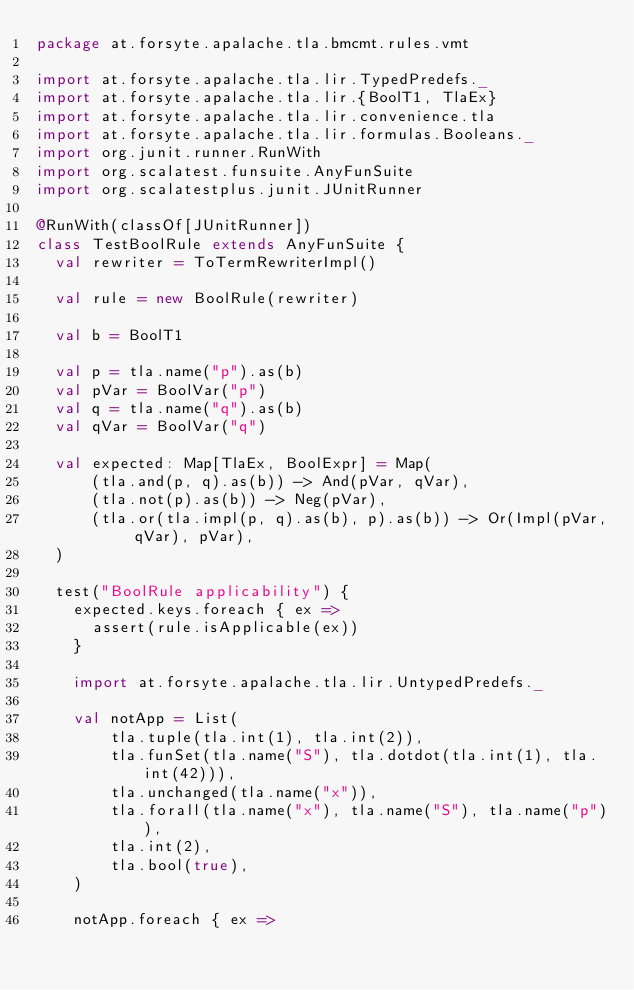<code> <loc_0><loc_0><loc_500><loc_500><_Scala_>package at.forsyte.apalache.tla.bmcmt.rules.vmt

import at.forsyte.apalache.tla.lir.TypedPredefs._
import at.forsyte.apalache.tla.lir.{BoolT1, TlaEx}
import at.forsyte.apalache.tla.lir.convenience.tla
import at.forsyte.apalache.tla.lir.formulas.Booleans._
import org.junit.runner.RunWith
import org.scalatest.funsuite.AnyFunSuite
import org.scalatestplus.junit.JUnitRunner

@RunWith(classOf[JUnitRunner])
class TestBoolRule extends AnyFunSuite {
  val rewriter = ToTermRewriterImpl()

  val rule = new BoolRule(rewriter)

  val b = BoolT1

  val p = tla.name("p").as(b)
  val pVar = BoolVar("p")
  val q = tla.name("q").as(b)
  val qVar = BoolVar("q")

  val expected: Map[TlaEx, BoolExpr] = Map(
      (tla.and(p, q).as(b)) -> And(pVar, qVar),
      (tla.not(p).as(b)) -> Neg(pVar),
      (tla.or(tla.impl(p, q).as(b), p).as(b)) -> Or(Impl(pVar, qVar), pVar),
  )

  test("BoolRule applicability") {
    expected.keys.foreach { ex =>
      assert(rule.isApplicable(ex))
    }

    import at.forsyte.apalache.tla.lir.UntypedPredefs._

    val notApp = List(
        tla.tuple(tla.int(1), tla.int(2)),
        tla.funSet(tla.name("S"), tla.dotdot(tla.int(1), tla.int(42))),
        tla.unchanged(tla.name("x")),
        tla.forall(tla.name("x"), tla.name("S"), tla.name("p")),
        tla.int(2),
        tla.bool(true),
    )

    notApp.foreach { ex =></code> 